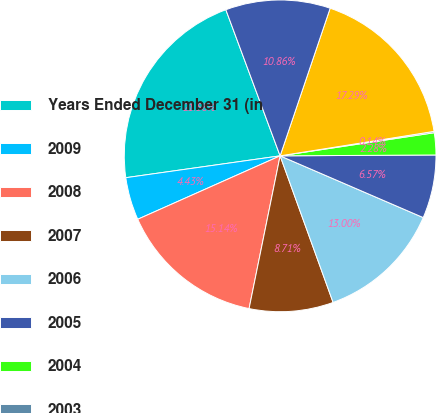<chart> <loc_0><loc_0><loc_500><loc_500><pie_chart><fcel>Years Ended December 31 (in<fcel>2009<fcel>2008<fcel>2007<fcel>2006<fcel>2005<fcel>2004<fcel>2003<fcel>2002 and prior<fcel>Total<nl><fcel>21.58%<fcel>4.43%<fcel>15.14%<fcel>8.71%<fcel>13.0%<fcel>6.57%<fcel>2.28%<fcel>0.14%<fcel>17.29%<fcel>10.86%<nl></chart> 